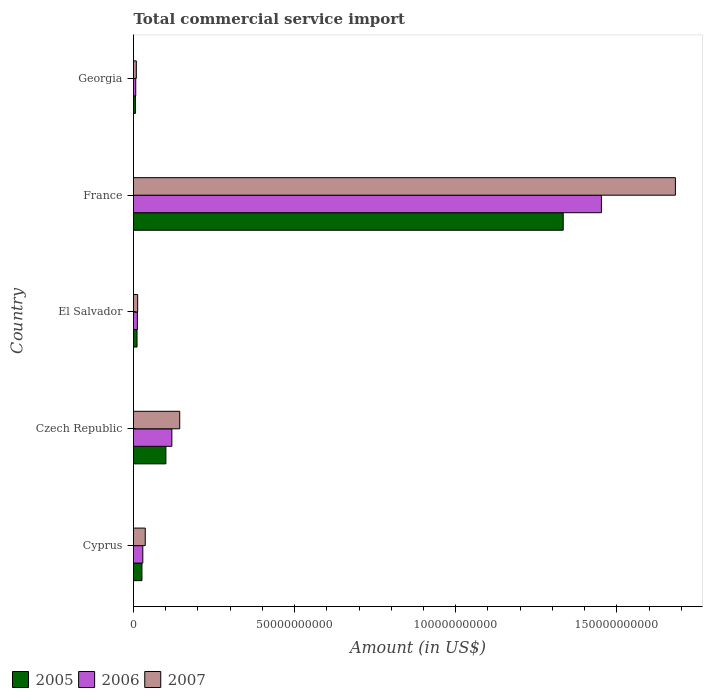How many different coloured bars are there?
Provide a short and direct response. 3. How many groups of bars are there?
Give a very brief answer. 5. Are the number of bars on each tick of the Y-axis equal?
Your answer should be compact. Yes. How many bars are there on the 3rd tick from the bottom?
Give a very brief answer. 3. What is the label of the 1st group of bars from the top?
Your response must be concise. Georgia. What is the total commercial service import in 2005 in El Salvador?
Ensure brevity in your answer.  1.09e+09. Across all countries, what is the maximum total commercial service import in 2005?
Your answer should be compact. 1.33e+11. Across all countries, what is the minimum total commercial service import in 2006?
Offer a terse response. 6.93e+08. In which country was the total commercial service import in 2005 minimum?
Make the answer very short. Georgia. What is the total total commercial service import in 2007 in the graph?
Provide a succinct answer. 1.88e+11. What is the difference between the total commercial service import in 2005 in Cyprus and that in France?
Your answer should be compact. -1.31e+11. What is the difference between the total commercial service import in 2005 in Cyprus and the total commercial service import in 2006 in Georgia?
Provide a short and direct response. 1.93e+09. What is the average total commercial service import in 2007 per country?
Offer a terse response. 3.77e+1. What is the difference between the total commercial service import in 2005 and total commercial service import in 2007 in Georgia?
Provide a succinct answer. -2.86e+08. In how many countries, is the total commercial service import in 2007 greater than 80000000000 US$?
Ensure brevity in your answer.  1. What is the ratio of the total commercial service import in 2005 in Czech Republic to that in France?
Provide a short and direct response. 0.08. Is the difference between the total commercial service import in 2005 in El Salvador and France greater than the difference between the total commercial service import in 2007 in El Salvador and France?
Give a very brief answer. Yes. What is the difference between the highest and the second highest total commercial service import in 2006?
Your answer should be very brief. 1.33e+11. What is the difference between the highest and the lowest total commercial service import in 2006?
Provide a succinct answer. 1.45e+11. Is the sum of the total commercial service import in 2007 in El Salvador and France greater than the maximum total commercial service import in 2006 across all countries?
Provide a short and direct response. Yes. What does the 1st bar from the bottom in France represents?
Your answer should be compact. 2005. Is it the case that in every country, the sum of the total commercial service import in 2007 and total commercial service import in 2006 is greater than the total commercial service import in 2005?
Make the answer very short. Yes. How many bars are there?
Give a very brief answer. 15. Are all the bars in the graph horizontal?
Make the answer very short. Yes. How many countries are there in the graph?
Your response must be concise. 5. Are the values on the major ticks of X-axis written in scientific E-notation?
Offer a very short reply. No. Does the graph contain any zero values?
Your answer should be very brief. No. Does the graph contain grids?
Your answer should be compact. No. Where does the legend appear in the graph?
Your answer should be compact. Bottom left. What is the title of the graph?
Give a very brief answer. Total commercial service import. What is the Amount (in US$) in 2005 in Cyprus?
Make the answer very short. 2.62e+09. What is the Amount (in US$) in 2006 in Cyprus?
Your response must be concise. 2.89e+09. What is the Amount (in US$) of 2007 in Cyprus?
Offer a terse response. 3.64e+09. What is the Amount (in US$) of 2005 in Czech Republic?
Offer a very short reply. 1.01e+1. What is the Amount (in US$) of 2006 in Czech Republic?
Provide a short and direct response. 1.19e+1. What is the Amount (in US$) of 2007 in Czech Republic?
Your answer should be compact. 1.43e+1. What is the Amount (in US$) in 2005 in El Salvador?
Give a very brief answer. 1.09e+09. What is the Amount (in US$) of 2006 in El Salvador?
Your answer should be compact. 1.21e+09. What is the Amount (in US$) of 2007 in El Salvador?
Keep it short and to the point. 1.29e+09. What is the Amount (in US$) in 2005 in France?
Give a very brief answer. 1.33e+11. What is the Amount (in US$) in 2006 in France?
Offer a very short reply. 1.45e+11. What is the Amount (in US$) of 2007 in France?
Ensure brevity in your answer.  1.68e+11. What is the Amount (in US$) of 2005 in Georgia?
Provide a succinct answer. 5.88e+08. What is the Amount (in US$) in 2006 in Georgia?
Offer a terse response. 6.93e+08. What is the Amount (in US$) in 2007 in Georgia?
Keep it short and to the point. 8.74e+08. Across all countries, what is the maximum Amount (in US$) in 2005?
Provide a short and direct response. 1.33e+11. Across all countries, what is the maximum Amount (in US$) of 2006?
Your answer should be compact. 1.45e+11. Across all countries, what is the maximum Amount (in US$) of 2007?
Provide a short and direct response. 1.68e+11. Across all countries, what is the minimum Amount (in US$) of 2005?
Ensure brevity in your answer.  5.88e+08. Across all countries, what is the minimum Amount (in US$) of 2006?
Provide a short and direct response. 6.93e+08. Across all countries, what is the minimum Amount (in US$) of 2007?
Your answer should be compact. 8.74e+08. What is the total Amount (in US$) in 2005 in the graph?
Provide a short and direct response. 1.48e+11. What is the total Amount (in US$) in 2006 in the graph?
Offer a very short reply. 1.62e+11. What is the total Amount (in US$) of 2007 in the graph?
Ensure brevity in your answer.  1.88e+11. What is the difference between the Amount (in US$) in 2005 in Cyprus and that in Czech Republic?
Give a very brief answer. -7.44e+09. What is the difference between the Amount (in US$) of 2006 in Cyprus and that in Czech Republic?
Offer a terse response. -9.01e+09. What is the difference between the Amount (in US$) in 2007 in Cyprus and that in Czech Republic?
Give a very brief answer. -1.07e+1. What is the difference between the Amount (in US$) of 2005 in Cyprus and that in El Salvador?
Keep it short and to the point. 1.53e+09. What is the difference between the Amount (in US$) of 2006 in Cyprus and that in El Salvador?
Ensure brevity in your answer.  1.68e+09. What is the difference between the Amount (in US$) of 2007 in Cyprus and that in El Salvador?
Ensure brevity in your answer.  2.35e+09. What is the difference between the Amount (in US$) of 2005 in Cyprus and that in France?
Provide a succinct answer. -1.31e+11. What is the difference between the Amount (in US$) in 2006 in Cyprus and that in France?
Provide a short and direct response. -1.42e+11. What is the difference between the Amount (in US$) of 2007 in Cyprus and that in France?
Ensure brevity in your answer.  -1.65e+11. What is the difference between the Amount (in US$) in 2005 in Cyprus and that in Georgia?
Provide a short and direct response. 2.03e+09. What is the difference between the Amount (in US$) in 2006 in Cyprus and that in Georgia?
Your response must be concise. 2.19e+09. What is the difference between the Amount (in US$) in 2007 in Cyprus and that in Georgia?
Offer a very short reply. 2.77e+09. What is the difference between the Amount (in US$) in 2005 in Czech Republic and that in El Salvador?
Make the answer very short. 8.96e+09. What is the difference between the Amount (in US$) of 2006 in Czech Republic and that in El Salvador?
Provide a succinct answer. 1.07e+1. What is the difference between the Amount (in US$) in 2007 in Czech Republic and that in El Salvador?
Your answer should be compact. 1.31e+1. What is the difference between the Amount (in US$) of 2005 in Czech Republic and that in France?
Offer a terse response. -1.23e+11. What is the difference between the Amount (in US$) of 2006 in Czech Republic and that in France?
Provide a short and direct response. -1.33e+11. What is the difference between the Amount (in US$) in 2007 in Czech Republic and that in France?
Offer a very short reply. -1.54e+11. What is the difference between the Amount (in US$) in 2005 in Czech Republic and that in Georgia?
Your response must be concise. 9.47e+09. What is the difference between the Amount (in US$) in 2006 in Czech Republic and that in Georgia?
Ensure brevity in your answer.  1.12e+1. What is the difference between the Amount (in US$) of 2007 in Czech Republic and that in Georgia?
Provide a succinct answer. 1.35e+1. What is the difference between the Amount (in US$) in 2005 in El Salvador and that in France?
Keep it short and to the point. -1.32e+11. What is the difference between the Amount (in US$) of 2006 in El Salvador and that in France?
Provide a succinct answer. -1.44e+11. What is the difference between the Amount (in US$) in 2007 in El Salvador and that in France?
Provide a succinct answer. -1.67e+11. What is the difference between the Amount (in US$) in 2005 in El Salvador and that in Georgia?
Offer a terse response. 5.05e+08. What is the difference between the Amount (in US$) in 2006 in El Salvador and that in Georgia?
Your response must be concise. 5.12e+08. What is the difference between the Amount (in US$) in 2007 in El Salvador and that in Georgia?
Provide a short and direct response. 4.16e+08. What is the difference between the Amount (in US$) in 2005 in France and that in Georgia?
Offer a terse response. 1.33e+11. What is the difference between the Amount (in US$) in 2006 in France and that in Georgia?
Provide a succinct answer. 1.45e+11. What is the difference between the Amount (in US$) in 2007 in France and that in Georgia?
Give a very brief answer. 1.67e+11. What is the difference between the Amount (in US$) of 2005 in Cyprus and the Amount (in US$) of 2006 in Czech Republic?
Provide a short and direct response. -9.28e+09. What is the difference between the Amount (in US$) in 2005 in Cyprus and the Amount (in US$) in 2007 in Czech Republic?
Ensure brevity in your answer.  -1.17e+1. What is the difference between the Amount (in US$) of 2006 in Cyprus and the Amount (in US$) of 2007 in Czech Republic?
Your answer should be compact. -1.15e+1. What is the difference between the Amount (in US$) in 2005 in Cyprus and the Amount (in US$) in 2006 in El Salvador?
Offer a terse response. 1.41e+09. What is the difference between the Amount (in US$) in 2005 in Cyprus and the Amount (in US$) in 2007 in El Salvador?
Give a very brief answer. 1.33e+09. What is the difference between the Amount (in US$) of 2006 in Cyprus and the Amount (in US$) of 2007 in El Salvador?
Provide a succinct answer. 1.60e+09. What is the difference between the Amount (in US$) in 2005 in Cyprus and the Amount (in US$) in 2006 in France?
Your answer should be very brief. -1.43e+11. What is the difference between the Amount (in US$) in 2005 in Cyprus and the Amount (in US$) in 2007 in France?
Your answer should be compact. -1.66e+11. What is the difference between the Amount (in US$) in 2006 in Cyprus and the Amount (in US$) in 2007 in France?
Your answer should be compact. -1.65e+11. What is the difference between the Amount (in US$) in 2005 in Cyprus and the Amount (in US$) in 2006 in Georgia?
Ensure brevity in your answer.  1.93e+09. What is the difference between the Amount (in US$) in 2005 in Cyprus and the Amount (in US$) in 2007 in Georgia?
Give a very brief answer. 1.75e+09. What is the difference between the Amount (in US$) of 2006 in Cyprus and the Amount (in US$) of 2007 in Georgia?
Your answer should be compact. 2.01e+09. What is the difference between the Amount (in US$) of 2005 in Czech Republic and the Amount (in US$) of 2006 in El Salvador?
Provide a short and direct response. 8.85e+09. What is the difference between the Amount (in US$) in 2005 in Czech Republic and the Amount (in US$) in 2007 in El Salvador?
Offer a very short reply. 8.77e+09. What is the difference between the Amount (in US$) in 2006 in Czech Republic and the Amount (in US$) in 2007 in El Salvador?
Keep it short and to the point. 1.06e+1. What is the difference between the Amount (in US$) of 2005 in Czech Republic and the Amount (in US$) of 2006 in France?
Make the answer very short. -1.35e+11. What is the difference between the Amount (in US$) of 2005 in Czech Republic and the Amount (in US$) of 2007 in France?
Provide a succinct answer. -1.58e+11. What is the difference between the Amount (in US$) in 2006 in Czech Republic and the Amount (in US$) in 2007 in France?
Your answer should be very brief. -1.56e+11. What is the difference between the Amount (in US$) of 2005 in Czech Republic and the Amount (in US$) of 2006 in Georgia?
Keep it short and to the point. 9.36e+09. What is the difference between the Amount (in US$) in 2005 in Czech Republic and the Amount (in US$) in 2007 in Georgia?
Make the answer very short. 9.18e+09. What is the difference between the Amount (in US$) of 2006 in Czech Republic and the Amount (in US$) of 2007 in Georgia?
Provide a short and direct response. 1.10e+1. What is the difference between the Amount (in US$) of 2005 in El Salvador and the Amount (in US$) of 2006 in France?
Your response must be concise. -1.44e+11. What is the difference between the Amount (in US$) in 2005 in El Salvador and the Amount (in US$) in 2007 in France?
Offer a terse response. -1.67e+11. What is the difference between the Amount (in US$) in 2006 in El Salvador and the Amount (in US$) in 2007 in France?
Provide a short and direct response. -1.67e+11. What is the difference between the Amount (in US$) of 2005 in El Salvador and the Amount (in US$) of 2006 in Georgia?
Your answer should be compact. 4.00e+08. What is the difference between the Amount (in US$) in 2005 in El Salvador and the Amount (in US$) in 2007 in Georgia?
Ensure brevity in your answer.  2.19e+08. What is the difference between the Amount (in US$) of 2006 in El Salvador and the Amount (in US$) of 2007 in Georgia?
Offer a terse response. 3.31e+08. What is the difference between the Amount (in US$) in 2005 in France and the Amount (in US$) in 2006 in Georgia?
Provide a short and direct response. 1.33e+11. What is the difference between the Amount (in US$) of 2005 in France and the Amount (in US$) of 2007 in Georgia?
Provide a succinct answer. 1.32e+11. What is the difference between the Amount (in US$) in 2006 in France and the Amount (in US$) in 2007 in Georgia?
Ensure brevity in your answer.  1.44e+11. What is the average Amount (in US$) of 2005 per country?
Give a very brief answer. 2.95e+1. What is the average Amount (in US$) in 2006 per country?
Provide a succinct answer. 3.24e+1. What is the average Amount (in US$) in 2007 per country?
Offer a terse response. 3.77e+1. What is the difference between the Amount (in US$) in 2005 and Amount (in US$) in 2006 in Cyprus?
Make the answer very short. -2.68e+08. What is the difference between the Amount (in US$) of 2005 and Amount (in US$) of 2007 in Cyprus?
Offer a very short reply. -1.02e+09. What is the difference between the Amount (in US$) in 2006 and Amount (in US$) in 2007 in Cyprus?
Give a very brief answer. -7.56e+08. What is the difference between the Amount (in US$) of 2005 and Amount (in US$) of 2006 in Czech Republic?
Keep it short and to the point. -1.84e+09. What is the difference between the Amount (in US$) in 2005 and Amount (in US$) in 2007 in Czech Republic?
Keep it short and to the point. -4.28e+09. What is the difference between the Amount (in US$) of 2006 and Amount (in US$) of 2007 in Czech Republic?
Your answer should be compact. -2.44e+09. What is the difference between the Amount (in US$) of 2005 and Amount (in US$) of 2006 in El Salvador?
Make the answer very short. -1.13e+08. What is the difference between the Amount (in US$) in 2005 and Amount (in US$) in 2007 in El Salvador?
Provide a succinct answer. -1.97e+08. What is the difference between the Amount (in US$) in 2006 and Amount (in US$) in 2007 in El Salvador?
Ensure brevity in your answer.  -8.46e+07. What is the difference between the Amount (in US$) of 2005 and Amount (in US$) of 2006 in France?
Your response must be concise. -1.19e+1. What is the difference between the Amount (in US$) in 2005 and Amount (in US$) in 2007 in France?
Provide a short and direct response. -3.48e+1. What is the difference between the Amount (in US$) of 2006 and Amount (in US$) of 2007 in France?
Your response must be concise. -2.30e+1. What is the difference between the Amount (in US$) in 2005 and Amount (in US$) in 2006 in Georgia?
Give a very brief answer. -1.05e+08. What is the difference between the Amount (in US$) in 2005 and Amount (in US$) in 2007 in Georgia?
Your response must be concise. -2.86e+08. What is the difference between the Amount (in US$) in 2006 and Amount (in US$) in 2007 in Georgia?
Offer a very short reply. -1.81e+08. What is the ratio of the Amount (in US$) in 2005 in Cyprus to that in Czech Republic?
Make the answer very short. 0.26. What is the ratio of the Amount (in US$) of 2006 in Cyprus to that in Czech Republic?
Ensure brevity in your answer.  0.24. What is the ratio of the Amount (in US$) of 2007 in Cyprus to that in Czech Republic?
Give a very brief answer. 0.25. What is the ratio of the Amount (in US$) in 2005 in Cyprus to that in El Salvador?
Offer a very short reply. 2.4. What is the ratio of the Amount (in US$) of 2006 in Cyprus to that in El Salvador?
Provide a succinct answer. 2.4. What is the ratio of the Amount (in US$) of 2007 in Cyprus to that in El Salvador?
Give a very brief answer. 2.83. What is the ratio of the Amount (in US$) of 2005 in Cyprus to that in France?
Your response must be concise. 0.02. What is the ratio of the Amount (in US$) in 2006 in Cyprus to that in France?
Offer a terse response. 0.02. What is the ratio of the Amount (in US$) of 2007 in Cyprus to that in France?
Make the answer very short. 0.02. What is the ratio of the Amount (in US$) of 2005 in Cyprus to that in Georgia?
Provide a short and direct response. 4.45. What is the ratio of the Amount (in US$) in 2006 in Cyprus to that in Georgia?
Your response must be concise. 4.17. What is the ratio of the Amount (in US$) in 2007 in Cyprus to that in Georgia?
Ensure brevity in your answer.  4.17. What is the ratio of the Amount (in US$) in 2005 in Czech Republic to that in El Salvador?
Provide a short and direct response. 9.2. What is the ratio of the Amount (in US$) in 2006 in Czech Republic to that in El Salvador?
Provide a succinct answer. 9.87. What is the ratio of the Amount (in US$) of 2007 in Czech Republic to that in El Salvador?
Your response must be concise. 11.12. What is the ratio of the Amount (in US$) in 2005 in Czech Republic to that in France?
Your answer should be compact. 0.08. What is the ratio of the Amount (in US$) in 2006 in Czech Republic to that in France?
Keep it short and to the point. 0.08. What is the ratio of the Amount (in US$) in 2007 in Czech Republic to that in France?
Your response must be concise. 0.09. What is the ratio of the Amount (in US$) of 2005 in Czech Republic to that in Georgia?
Your answer should be compact. 17.1. What is the ratio of the Amount (in US$) of 2006 in Czech Republic to that in Georgia?
Keep it short and to the point. 17.17. What is the ratio of the Amount (in US$) in 2007 in Czech Republic to that in Georgia?
Keep it short and to the point. 16.41. What is the ratio of the Amount (in US$) in 2005 in El Salvador to that in France?
Offer a terse response. 0.01. What is the ratio of the Amount (in US$) in 2006 in El Salvador to that in France?
Offer a very short reply. 0.01. What is the ratio of the Amount (in US$) in 2007 in El Salvador to that in France?
Your answer should be very brief. 0.01. What is the ratio of the Amount (in US$) of 2005 in El Salvador to that in Georgia?
Your answer should be very brief. 1.86. What is the ratio of the Amount (in US$) of 2006 in El Salvador to that in Georgia?
Your answer should be very brief. 1.74. What is the ratio of the Amount (in US$) of 2007 in El Salvador to that in Georgia?
Give a very brief answer. 1.48. What is the ratio of the Amount (in US$) in 2005 in France to that in Georgia?
Give a very brief answer. 226.73. What is the ratio of the Amount (in US$) of 2006 in France to that in Georgia?
Offer a very short reply. 209.51. What is the ratio of the Amount (in US$) of 2007 in France to that in Georgia?
Offer a terse response. 192.41. What is the difference between the highest and the second highest Amount (in US$) in 2005?
Give a very brief answer. 1.23e+11. What is the difference between the highest and the second highest Amount (in US$) in 2006?
Ensure brevity in your answer.  1.33e+11. What is the difference between the highest and the second highest Amount (in US$) of 2007?
Ensure brevity in your answer.  1.54e+11. What is the difference between the highest and the lowest Amount (in US$) in 2005?
Keep it short and to the point. 1.33e+11. What is the difference between the highest and the lowest Amount (in US$) in 2006?
Provide a short and direct response. 1.45e+11. What is the difference between the highest and the lowest Amount (in US$) in 2007?
Provide a short and direct response. 1.67e+11. 